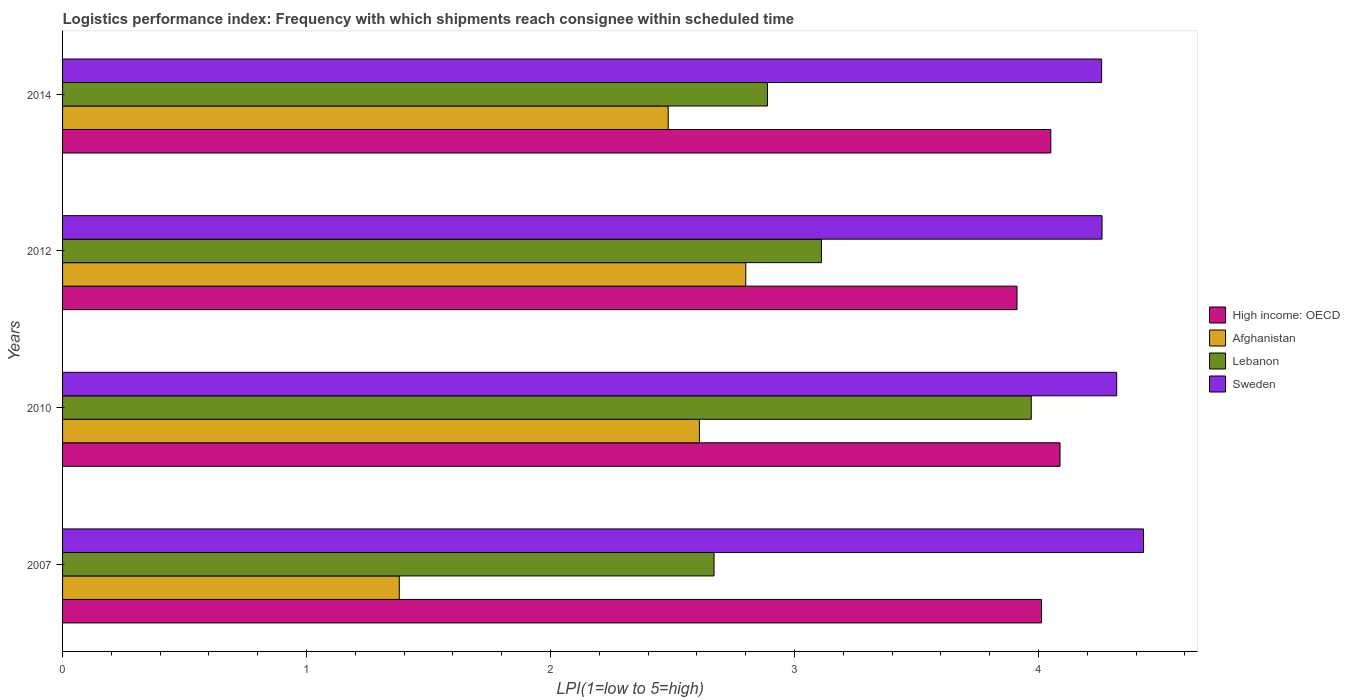How many different coloured bars are there?
Offer a very short reply. 4. How many groups of bars are there?
Offer a very short reply. 4. Are the number of bars on each tick of the Y-axis equal?
Your answer should be compact. Yes. What is the logistics performance index in High income: OECD in 2012?
Provide a succinct answer. 3.91. Across all years, what is the maximum logistics performance index in High income: OECD?
Make the answer very short. 4.09. Across all years, what is the minimum logistics performance index in Lebanon?
Offer a terse response. 2.67. In which year was the logistics performance index in Afghanistan minimum?
Keep it short and to the point. 2007. What is the total logistics performance index in Afghanistan in the graph?
Offer a terse response. 9.27. What is the difference between the logistics performance index in Lebanon in 2007 and that in 2010?
Your answer should be compact. -1.3. What is the difference between the logistics performance index in Afghanistan in 2010 and the logistics performance index in Sweden in 2007?
Give a very brief answer. -1.82. What is the average logistics performance index in High income: OECD per year?
Your answer should be compact. 4.02. In the year 2012, what is the difference between the logistics performance index in Sweden and logistics performance index in Afghanistan?
Offer a very short reply. 1.46. In how many years, is the logistics performance index in Sweden greater than 1.8 ?
Provide a short and direct response. 4. What is the ratio of the logistics performance index in High income: OECD in 2007 to that in 2012?
Make the answer very short. 1.03. Is the logistics performance index in High income: OECD in 2010 less than that in 2012?
Make the answer very short. No. Is the difference between the logistics performance index in Sweden in 2007 and 2012 greater than the difference between the logistics performance index in Afghanistan in 2007 and 2012?
Your answer should be compact. Yes. What is the difference between the highest and the second highest logistics performance index in High income: OECD?
Ensure brevity in your answer.  0.04. What is the difference between the highest and the lowest logistics performance index in Lebanon?
Make the answer very short. 1.3. In how many years, is the logistics performance index in Lebanon greater than the average logistics performance index in Lebanon taken over all years?
Offer a terse response. 1. Is it the case that in every year, the sum of the logistics performance index in High income: OECD and logistics performance index in Afghanistan is greater than the sum of logistics performance index in Lebanon and logistics performance index in Sweden?
Your answer should be very brief. Yes. What does the 2nd bar from the top in 2007 represents?
Your response must be concise. Lebanon. What does the 1st bar from the bottom in 2010 represents?
Ensure brevity in your answer.  High income: OECD. Is it the case that in every year, the sum of the logistics performance index in Lebanon and logistics performance index in Sweden is greater than the logistics performance index in High income: OECD?
Keep it short and to the point. Yes. How many years are there in the graph?
Your answer should be compact. 4. Are the values on the major ticks of X-axis written in scientific E-notation?
Give a very brief answer. No. Does the graph contain grids?
Offer a terse response. No. How many legend labels are there?
Keep it short and to the point. 4. How are the legend labels stacked?
Give a very brief answer. Vertical. What is the title of the graph?
Your answer should be very brief. Logistics performance index: Frequency with which shipments reach consignee within scheduled time. What is the label or title of the X-axis?
Your response must be concise. LPI(1=low to 5=high). What is the LPI(1=low to 5=high) in High income: OECD in 2007?
Provide a succinct answer. 4.01. What is the LPI(1=low to 5=high) in Afghanistan in 2007?
Provide a short and direct response. 1.38. What is the LPI(1=low to 5=high) in Lebanon in 2007?
Your answer should be compact. 2.67. What is the LPI(1=low to 5=high) in Sweden in 2007?
Keep it short and to the point. 4.43. What is the LPI(1=low to 5=high) in High income: OECD in 2010?
Make the answer very short. 4.09. What is the LPI(1=low to 5=high) in Afghanistan in 2010?
Offer a very short reply. 2.61. What is the LPI(1=low to 5=high) of Lebanon in 2010?
Make the answer very short. 3.97. What is the LPI(1=low to 5=high) of Sweden in 2010?
Offer a terse response. 4.32. What is the LPI(1=low to 5=high) in High income: OECD in 2012?
Give a very brief answer. 3.91. What is the LPI(1=low to 5=high) in Afghanistan in 2012?
Keep it short and to the point. 2.8. What is the LPI(1=low to 5=high) of Lebanon in 2012?
Provide a short and direct response. 3.11. What is the LPI(1=low to 5=high) in Sweden in 2012?
Provide a succinct answer. 4.26. What is the LPI(1=low to 5=high) in High income: OECD in 2014?
Your answer should be compact. 4.05. What is the LPI(1=low to 5=high) in Afghanistan in 2014?
Your answer should be compact. 2.48. What is the LPI(1=low to 5=high) of Lebanon in 2014?
Offer a very short reply. 2.89. What is the LPI(1=low to 5=high) of Sweden in 2014?
Give a very brief answer. 4.26. Across all years, what is the maximum LPI(1=low to 5=high) of High income: OECD?
Offer a very short reply. 4.09. Across all years, what is the maximum LPI(1=low to 5=high) of Lebanon?
Give a very brief answer. 3.97. Across all years, what is the maximum LPI(1=low to 5=high) in Sweden?
Make the answer very short. 4.43. Across all years, what is the minimum LPI(1=low to 5=high) of High income: OECD?
Provide a succinct answer. 3.91. Across all years, what is the minimum LPI(1=low to 5=high) of Afghanistan?
Your answer should be compact. 1.38. Across all years, what is the minimum LPI(1=low to 5=high) of Lebanon?
Your response must be concise. 2.67. Across all years, what is the minimum LPI(1=low to 5=high) of Sweden?
Offer a very short reply. 4.26. What is the total LPI(1=low to 5=high) in High income: OECD in the graph?
Make the answer very short. 16.06. What is the total LPI(1=low to 5=high) of Afghanistan in the graph?
Offer a terse response. 9.27. What is the total LPI(1=low to 5=high) in Lebanon in the graph?
Keep it short and to the point. 12.64. What is the total LPI(1=low to 5=high) of Sweden in the graph?
Ensure brevity in your answer.  17.27. What is the difference between the LPI(1=low to 5=high) of High income: OECD in 2007 and that in 2010?
Ensure brevity in your answer.  -0.08. What is the difference between the LPI(1=low to 5=high) of Afghanistan in 2007 and that in 2010?
Make the answer very short. -1.23. What is the difference between the LPI(1=low to 5=high) of Lebanon in 2007 and that in 2010?
Provide a short and direct response. -1.3. What is the difference between the LPI(1=low to 5=high) in Sweden in 2007 and that in 2010?
Provide a short and direct response. 0.11. What is the difference between the LPI(1=low to 5=high) of High income: OECD in 2007 and that in 2012?
Give a very brief answer. 0.1. What is the difference between the LPI(1=low to 5=high) in Afghanistan in 2007 and that in 2012?
Your response must be concise. -1.42. What is the difference between the LPI(1=low to 5=high) in Lebanon in 2007 and that in 2012?
Your answer should be compact. -0.44. What is the difference between the LPI(1=low to 5=high) of Sweden in 2007 and that in 2012?
Make the answer very short. 0.17. What is the difference between the LPI(1=low to 5=high) in High income: OECD in 2007 and that in 2014?
Your response must be concise. -0.04. What is the difference between the LPI(1=low to 5=high) in Afghanistan in 2007 and that in 2014?
Ensure brevity in your answer.  -1.1. What is the difference between the LPI(1=low to 5=high) in Lebanon in 2007 and that in 2014?
Your answer should be very brief. -0.22. What is the difference between the LPI(1=low to 5=high) of Sweden in 2007 and that in 2014?
Provide a succinct answer. 0.17. What is the difference between the LPI(1=low to 5=high) in High income: OECD in 2010 and that in 2012?
Provide a succinct answer. 0.18. What is the difference between the LPI(1=low to 5=high) in Afghanistan in 2010 and that in 2012?
Provide a succinct answer. -0.19. What is the difference between the LPI(1=low to 5=high) in Lebanon in 2010 and that in 2012?
Ensure brevity in your answer.  0.86. What is the difference between the LPI(1=low to 5=high) in High income: OECD in 2010 and that in 2014?
Offer a terse response. 0.04. What is the difference between the LPI(1=low to 5=high) in Afghanistan in 2010 and that in 2014?
Ensure brevity in your answer.  0.13. What is the difference between the LPI(1=low to 5=high) in Lebanon in 2010 and that in 2014?
Your response must be concise. 1.08. What is the difference between the LPI(1=low to 5=high) in Sweden in 2010 and that in 2014?
Provide a short and direct response. 0.06. What is the difference between the LPI(1=low to 5=high) in High income: OECD in 2012 and that in 2014?
Your answer should be compact. -0.14. What is the difference between the LPI(1=low to 5=high) in Afghanistan in 2012 and that in 2014?
Give a very brief answer. 0.32. What is the difference between the LPI(1=low to 5=high) in Lebanon in 2012 and that in 2014?
Provide a short and direct response. 0.22. What is the difference between the LPI(1=low to 5=high) in Sweden in 2012 and that in 2014?
Your response must be concise. 0. What is the difference between the LPI(1=low to 5=high) in High income: OECD in 2007 and the LPI(1=low to 5=high) in Afghanistan in 2010?
Your answer should be compact. 1.4. What is the difference between the LPI(1=low to 5=high) of High income: OECD in 2007 and the LPI(1=low to 5=high) of Lebanon in 2010?
Make the answer very short. 0.04. What is the difference between the LPI(1=low to 5=high) in High income: OECD in 2007 and the LPI(1=low to 5=high) in Sweden in 2010?
Give a very brief answer. -0.31. What is the difference between the LPI(1=low to 5=high) of Afghanistan in 2007 and the LPI(1=low to 5=high) of Lebanon in 2010?
Provide a short and direct response. -2.59. What is the difference between the LPI(1=low to 5=high) of Afghanistan in 2007 and the LPI(1=low to 5=high) of Sweden in 2010?
Provide a succinct answer. -2.94. What is the difference between the LPI(1=low to 5=high) in Lebanon in 2007 and the LPI(1=low to 5=high) in Sweden in 2010?
Offer a very short reply. -1.65. What is the difference between the LPI(1=low to 5=high) in High income: OECD in 2007 and the LPI(1=low to 5=high) in Afghanistan in 2012?
Ensure brevity in your answer.  1.21. What is the difference between the LPI(1=low to 5=high) of High income: OECD in 2007 and the LPI(1=low to 5=high) of Lebanon in 2012?
Your response must be concise. 0.9. What is the difference between the LPI(1=low to 5=high) of High income: OECD in 2007 and the LPI(1=low to 5=high) of Sweden in 2012?
Make the answer very short. -0.25. What is the difference between the LPI(1=low to 5=high) of Afghanistan in 2007 and the LPI(1=low to 5=high) of Lebanon in 2012?
Provide a succinct answer. -1.73. What is the difference between the LPI(1=low to 5=high) of Afghanistan in 2007 and the LPI(1=low to 5=high) of Sweden in 2012?
Keep it short and to the point. -2.88. What is the difference between the LPI(1=low to 5=high) in Lebanon in 2007 and the LPI(1=low to 5=high) in Sweden in 2012?
Offer a terse response. -1.59. What is the difference between the LPI(1=low to 5=high) of High income: OECD in 2007 and the LPI(1=low to 5=high) of Afghanistan in 2014?
Keep it short and to the point. 1.53. What is the difference between the LPI(1=low to 5=high) in High income: OECD in 2007 and the LPI(1=low to 5=high) in Lebanon in 2014?
Your response must be concise. 1.12. What is the difference between the LPI(1=low to 5=high) of High income: OECD in 2007 and the LPI(1=low to 5=high) of Sweden in 2014?
Offer a terse response. -0.25. What is the difference between the LPI(1=low to 5=high) in Afghanistan in 2007 and the LPI(1=low to 5=high) in Lebanon in 2014?
Make the answer very short. -1.51. What is the difference between the LPI(1=low to 5=high) in Afghanistan in 2007 and the LPI(1=low to 5=high) in Sweden in 2014?
Provide a short and direct response. -2.88. What is the difference between the LPI(1=low to 5=high) in Lebanon in 2007 and the LPI(1=low to 5=high) in Sweden in 2014?
Your answer should be very brief. -1.59. What is the difference between the LPI(1=low to 5=high) of High income: OECD in 2010 and the LPI(1=low to 5=high) of Afghanistan in 2012?
Provide a succinct answer. 1.29. What is the difference between the LPI(1=low to 5=high) of High income: OECD in 2010 and the LPI(1=low to 5=high) of Lebanon in 2012?
Give a very brief answer. 0.98. What is the difference between the LPI(1=low to 5=high) in High income: OECD in 2010 and the LPI(1=low to 5=high) in Sweden in 2012?
Your answer should be compact. -0.17. What is the difference between the LPI(1=low to 5=high) in Afghanistan in 2010 and the LPI(1=low to 5=high) in Sweden in 2012?
Your response must be concise. -1.65. What is the difference between the LPI(1=low to 5=high) of Lebanon in 2010 and the LPI(1=low to 5=high) of Sweden in 2012?
Your response must be concise. -0.29. What is the difference between the LPI(1=low to 5=high) in High income: OECD in 2010 and the LPI(1=low to 5=high) in Afghanistan in 2014?
Provide a succinct answer. 1.61. What is the difference between the LPI(1=low to 5=high) in High income: OECD in 2010 and the LPI(1=low to 5=high) in Lebanon in 2014?
Give a very brief answer. 1.2. What is the difference between the LPI(1=low to 5=high) of High income: OECD in 2010 and the LPI(1=low to 5=high) of Sweden in 2014?
Offer a terse response. -0.17. What is the difference between the LPI(1=low to 5=high) of Afghanistan in 2010 and the LPI(1=low to 5=high) of Lebanon in 2014?
Make the answer very short. -0.28. What is the difference between the LPI(1=low to 5=high) of Afghanistan in 2010 and the LPI(1=low to 5=high) of Sweden in 2014?
Provide a succinct answer. -1.65. What is the difference between the LPI(1=low to 5=high) of Lebanon in 2010 and the LPI(1=low to 5=high) of Sweden in 2014?
Provide a succinct answer. -0.29. What is the difference between the LPI(1=low to 5=high) in High income: OECD in 2012 and the LPI(1=low to 5=high) in Afghanistan in 2014?
Offer a terse response. 1.43. What is the difference between the LPI(1=low to 5=high) in High income: OECD in 2012 and the LPI(1=low to 5=high) in Lebanon in 2014?
Ensure brevity in your answer.  1.02. What is the difference between the LPI(1=low to 5=high) in High income: OECD in 2012 and the LPI(1=low to 5=high) in Sweden in 2014?
Your answer should be very brief. -0.35. What is the difference between the LPI(1=low to 5=high) in Afghanistan in 2012 and the LPI(1=low to 5=high) in Lebanon in 2014?
Keep it short and to the point. -0.09. What is the difference between the LPI(1=low to 5=high) in Afghanistan in 2012 and the LPI(1=low to 5=high) in Sweden in 2014?
Offer a terse response. -1.46. What is the difference between the LPI(1=low to 5=high) of Lebanon in 2012 and the LPI(1=low to 5=high) of Sweden in 2014?
Your answer should be compact. -1.15. What is the average LPI(1=low to 5=high) in High income: OECD per year?
Offer a terse response. 4.02. What is the average LPI(1=low to 5=high) of Afghanistan per year?
Keep it short and to the point. 2.32. What is the average LPI(1=low to 5=high) in Lebanon per year?
Give a very brief answer. 3.16. What is the average LPI(1=low to 5=high) in Sweden per year?
Keep it short and to the point. 4.32. In the year 2007, what is the difference between the LPI(1=low to 5=high) in High income: OECD and LPI(1=low to 5=high) in Afghanistan?
Offer a terse response. 2.63. In the year 2007, what is the difference between the LPI(1=low to 5=high) of High income: OECD and LPI(1=low to 5=high) of Lebanon?
Ensure brevity in your answer.  1.34. In the year 2007, what is the difference between the LPI(1=low to 5=high) in High income: OECD and LPI(1=low to 5=high) in Sweden?
Offer a terse response. -0.42. In the year 2007, what is the difference between the LPI(1=low to 5=high) in Afghanistan and LPI(1=low to 5=high) in Lebanon?
Keep it short and to the point. -1.29. In the year 2007, what is the difference between the LPI(1=low to 5=high) of Afghanistan and LPI(1=low to 5=high) of Sweden?
Ensure brevity in your answer.  -3.05. In the year 2007, what is the difference between the LPI(1=low to 5=high) of Lebanon and LPI(1=low to 5=high) of Sweden?
Make the answer very short. -1.76. In the year 2010, what is the difference between the LPI(1=low to 5=high) of High income: OECD and LPI(1=low to 5=high) of Afghanistan?
Keep it short and to the point. 1.48. In the year 2010, what is the difference between the LPI(1=low to 5=high) in High income: OECD and LPI(1=low to 5=high) in Lebanon?
Give a very brief answer. 0.12. In the year 2010, what is the difference between the LPI(1=low to 5=high) of High income: OECD and LPI(1=low to 5=high) of Sweden?
Your response must be concise. -0.23. In the year 2010, what is the difference between the LPI(1=low to 5=high) of Afghanistan and LPI(1=low to 5=high) of Lebanon?
Your answer should be compact. -1.36. In the year 2010, what is the difference between the LPI(1=low to 5=high) in Afghanistan and LPI(1=low to 5=high) in Sweden?
Give a very brief answer. -1.71. In the year 2010, what is the difference between the LPI(1=low to 5=high) of Lebanon and LPI(1=low to 5=high) of Sweden?
Your response must be concise. -0.35. In the year 2012, what is the difference between the LPI(1=low to 5=high) in High income: OECD and LPI(1=low to 5=high) in Afghanistan?
Your response must be concise. 1.11. In the year 2012, what is the difference between the LPI(1=low to 5=high) in High income: OECD and LPI(1=low to 5=high) in Lebanon?
Give a very brief answer. 0.8. In the year 2012, what is the difference between the LPI(1=low to 5=high) of High income: OECD and LPI(1=low to 5=high) of Sweden?
Your answer should be very brief. -0.35. In the year 2012, what is the difference between the LPI(1=low to 5=high) of Afghanistan and LPI(1=low to 5=high) of Lebanon?
Provide a succinct answer. -0.31. In the year 2012, what is the difference between the LPI(1=low to 5=high) in Afghanistan and LPI(1=low to 5=high) in Sweden?
Your response must be concise. -1.46. In the year 2012, what is the difference between the LPI(1=low to 5=high) in Lebanon and LPI(1=low to 5=high) in Sweden?
Keep it short and to the point. -1.15. In the year 2014, what is the difference between the LPI(1=low to 5=high) in High income: OECD and LPI(1=low to 5=high) in Afghanistan?
Offer a very short reply. 1.57. In the year 2014, what is the difference between the LPI(1=low to 5=high) of High income: OECD and LPI(1=low to 5=high) of Lebanon?
Your response must be concise. 1.16. In the year 2014, what is the difference between the LPI(1=low to 5=high) of High income: OECD and LPI(1=low to 5=high) of Sweden?
Offer a terse response. -0.21. In the year 2014, what is the difference between the LPI(1=low to 5=high) in Afghanistan and LPI(1=low to 5=high) in Lebanon?
Your answer should be compact. -0.41. In the year 2014, what is the difference between the LPI(1=low to 5=high) of Afghanistan and LPI(1=low to 5=high) of Sweden?
Your response must be concise. -1.78. In the year 2014, what is the difference between the LPI(1=low to 5=high) in Lebanon and LPI(1=low to 5=high) in Sweden?
Your answer should be compact. -1.37. What is the ratio of the LPI(1=low to 5=high) of High income: OECD in 2007 to that in 2010?
Offer a very short reply. 0.98. What is the ratio of the LPI(1=low to 5=high) in Afghanistan in 2007 to that in 2010?
Offer a terse response. 0.53. What is the ratio of the LPI(1=low to 5=high) of Lebanon in 2007 to that in 2010?
Provide a short and direct response. 0.67. What is the ratio of the LPI(1=low to 5=high) of Sweden in 2007 to that in 2010?
Give a very brief answer. 1.03. What is the ratio of the LPI(1=low to 5=high) of High income: OECD in 2007 to that in 2012?
Make the answer very short. 1.03. What is the ratio of the LPI(1=low to 5=high) in Afghanistan in 2007 to that in 2012?
Ensure brevity in your answer.  0.49. What is the ratio of the LPI(1=low to 5=high) of Lebanon in 2007 to that in 2012?
Give a very brief answer. 0.86. What is the ratio of the LPI(1=low to 5=high) of Sweden in 2007 to that in 2012?
Ensure brevity in your answer.  1.04. What is the ratio of the LPI(1=low to 5=high) in High income: OECD in 2007 to that in 2014?
Give a very brief answer. 0.99. What is the ratio of the LPI(1=low to 5=high) of Afghanistan in 2007 to that in 2014?
Offer a terse response. 0.56. What is the ratio of the LPI(1=low to 5=high) in Lebanon in 2007 to that in 2014?
Your answer should be compact. 0.92. What is the ratio of the LPI(1=low to 5=high) of Sweden in 2007 to that in 2014?
Offer a very short reply. 1.04. What is the ratio of the LPI(1=low to 5=high) in High income: OECD in 2010 to that in 2012?
Offer a very short reply. 1.04. What is the ratio of the LPI(1=low to 5=high) in Afghanistan in 2010 to that in 2012?
Provide a short and direct response. 0.93. What is the ratio of the LPI(1=low to 5=high) of Lebanon in 2010 to that in 2012?
Offer a terse response. 1.28. What is the ratio of the LPI(1=low to 5=high) in Sweden in 2010 to that in 2012?
Offer a very short reply. 1.01. What is the ratio of the LPI(1=low to 5=high) of High income: OECD in 2010 to that in 2014?
Your answer should be very brief. 1.01. What is the ratio of the LPI(1=low to 5=high) in Afghanistan in 2010 to that in 2014?
Your answer should be compact. 1.05. What is the ratio of the LPI(1=low to 5=high) of Lebanon in 2010 to that in 2014?
Provide a short and direct response. 1.37. What is the ratio of the LPI(1=low to 5=high) of Sweden in 2010 to that in 2014?
Give a very brief answer. 1.01. What is the ratio of the LPI(1=low to 5=high) in High income: OECD in 2012 to that in 2014?
Offer a very short reply. 0.97. What is the ratio of the LPI(1=low to 5=high) of Afghanistan in 2012 to that in 2014?
Your response must be concise. 1.13. What is the ratio of the LPI(1=low to 5=high) in Lebanon in 2012 to that in 2014?
Provide a short and direct response. 1.08. What is the difference between the highest and the second highest LPI(1=low to 5=high) of High income: OECD?
Keep it short and to the point. 0.04. What is the difference between the highest and the second highest LPI(1=low to 5=high) in Afghanistan?
Offer a terse response. 0.19. What is the difference between the highest and the second highest LPI(1=low to 5=high) of Lebanon?
Offer a terse response. 0.86. What is the difference between the highest and the second highest LPI(1=low to 5=high) in Sweden?
Your answer should be compact. 0.11. What is the difference between the highest and the lowest LPI(1=low to 5=high) in High income: OECD?
Your response must be concise. 0.18. What is the difference between the highest and the lowest LPI(1=low to 5=high) in Afghanistan?
Ensure brevity in your answer.  1.42. What is the difference between the highest and the lowest LPI(1=low to 5=high) in Sweden?
Your answer should be compact. 0.17. 